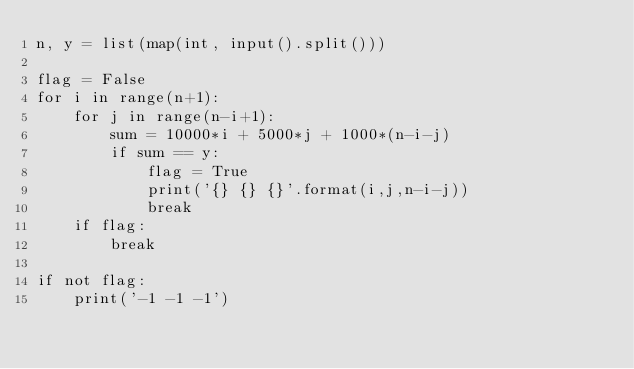Convert code to text. <code><loc_0><loc_0><loc_500><loc_500><_Python_>n, y = list(map(int, input().split()))

flag = False
for i in range(n+1):
    for j in range(n-i+1):
        sum = 10000*i + 5000*j + 1000*(n-i-j)
        if sum == y:
            flag = True
            print('{} {} {}'.format(i,j,n-i-j))
            break
    if flag:
        break

if not flag:
    print('-1 -1 -1')
</code> 